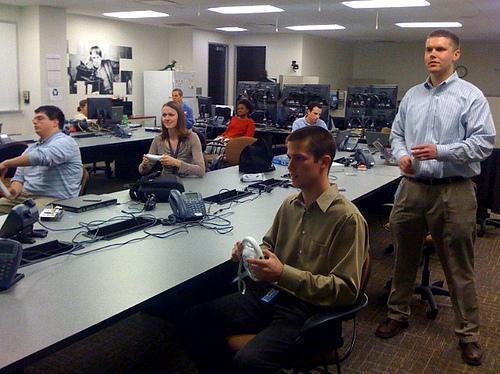What is the man in the brown shirt emulating with the white controller?
Indicate the correct response by choosing from the four available options to answer the question.
Options: Driving, shooting, boxing, skiing. Driving. 